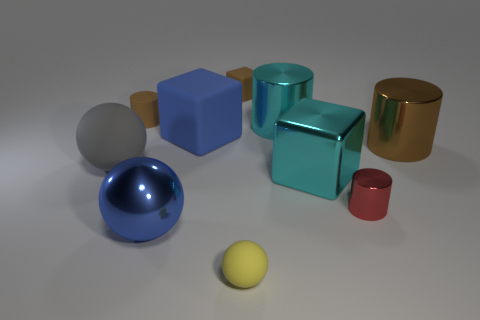Subtract all red metallic cylinders. How many cylinders are left? 3 Subtract 1 cylinders. How many cylinders are left? 3 Subtract all blue cylinders. Subtract all yellow balls. How many cylinders are left? 4 Subtract all cylinders. How many objects are left? 6 Subtract 0 gray cubes. How many objects are left? 10 Subtract all large gray rubber spheres. Subtract all small yellow objects. How many objects are left? 8 Add 7 cyan things. How many cyan things are left? 9 Add 2 large cyan matte blocks. How many large cyan matte blocks exist? 2 